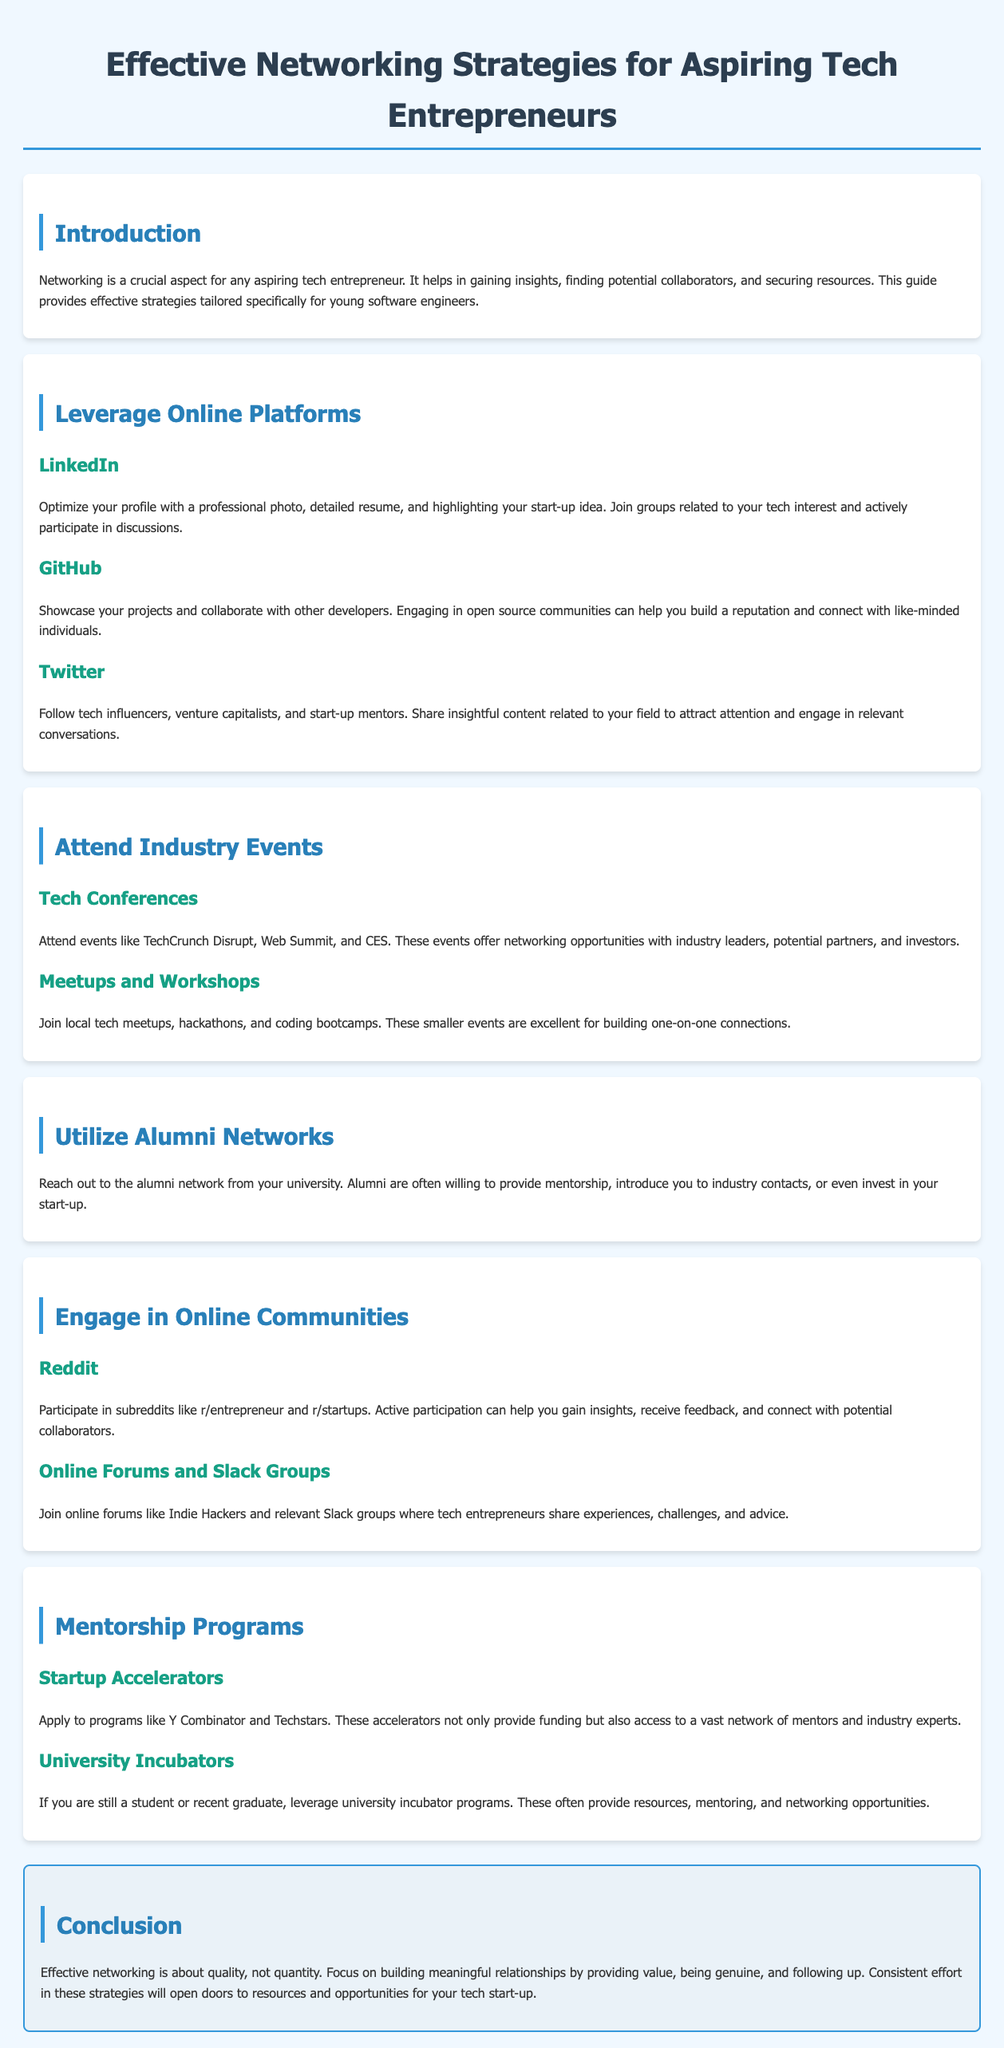what is the title of the document? The title of the document is indicated in the header section of the HTML code.
Answer: Effective Networking Strategies for Aspiring Tech Entrepreneurs how many online platforms are mentioned? The document lists three online platforms under the "Leverage Online Platforms" section.
Answer: Three name one tech conference recommended for networking. The document lists several tech conferences as examples for networking; one is specified in the "Attend Industry Events" section.
Answer: TechCrunch Disrupt what color is used for the conclusion section? The color of the conclusion section is stated in the CSS styling applied to that specific section.
Answer: #eaf2f8 how can alumni networks be useful? This information is found in the "Utilize Alumni Networks" section, describing how these networks can help.
Answer: Mentorship, introductions, investment which platform is suggested for showcasing projects? The document explicitly mentions a platform under "Leverage Online Platforms" for this purpose.
Answer: GitHub what is the primary focus of effective networking? The final section summarizes the overall approach to networking.
Answer: Quality, not quantity which programs are mentioned for mentorship opportunities? The document lists two specific programs where aspiring entrepreneurs can seek mentorship.
Answer: Y Combinator, Techstars 